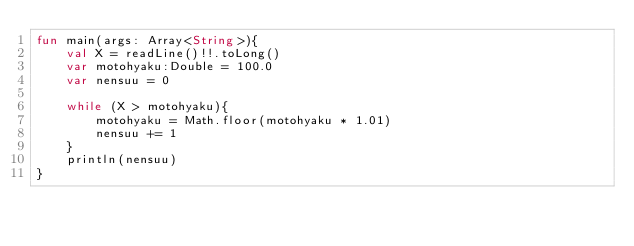Convert code to text. <code><loc_0><loc_0><loc_500><loc_500><_Kotlin_>fun main(args: Array<String>){
    val X = readLine()!!.toLong()
    var motohyaku:Double = 100.0
    var nensuu = 0

    while (X > motohyaku){
        motohyaku = Math.floor(motohyaku * 1.01)
        nensuu += 1
    }
    println(nensuu)
}</code> 